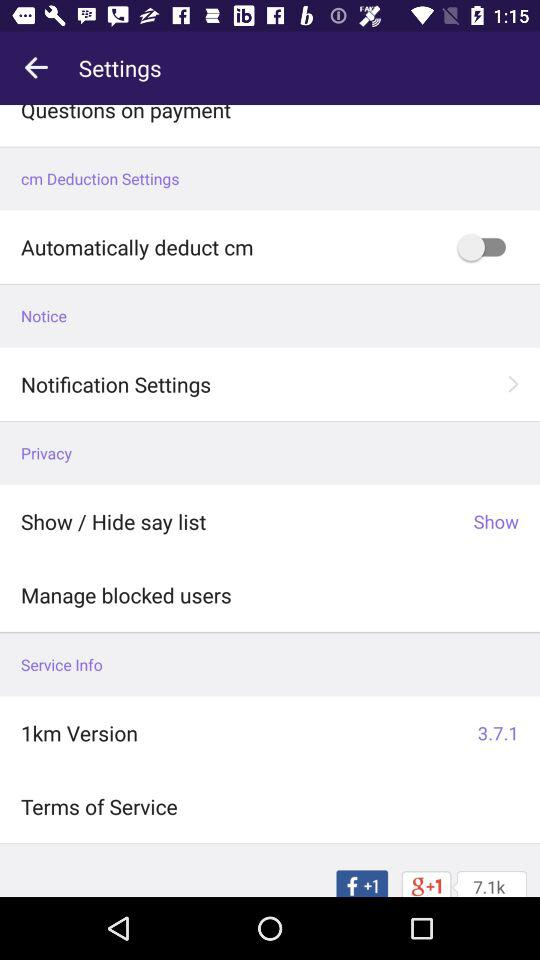What is the version of "1km"? The version of "1km" is 3.7.1. 